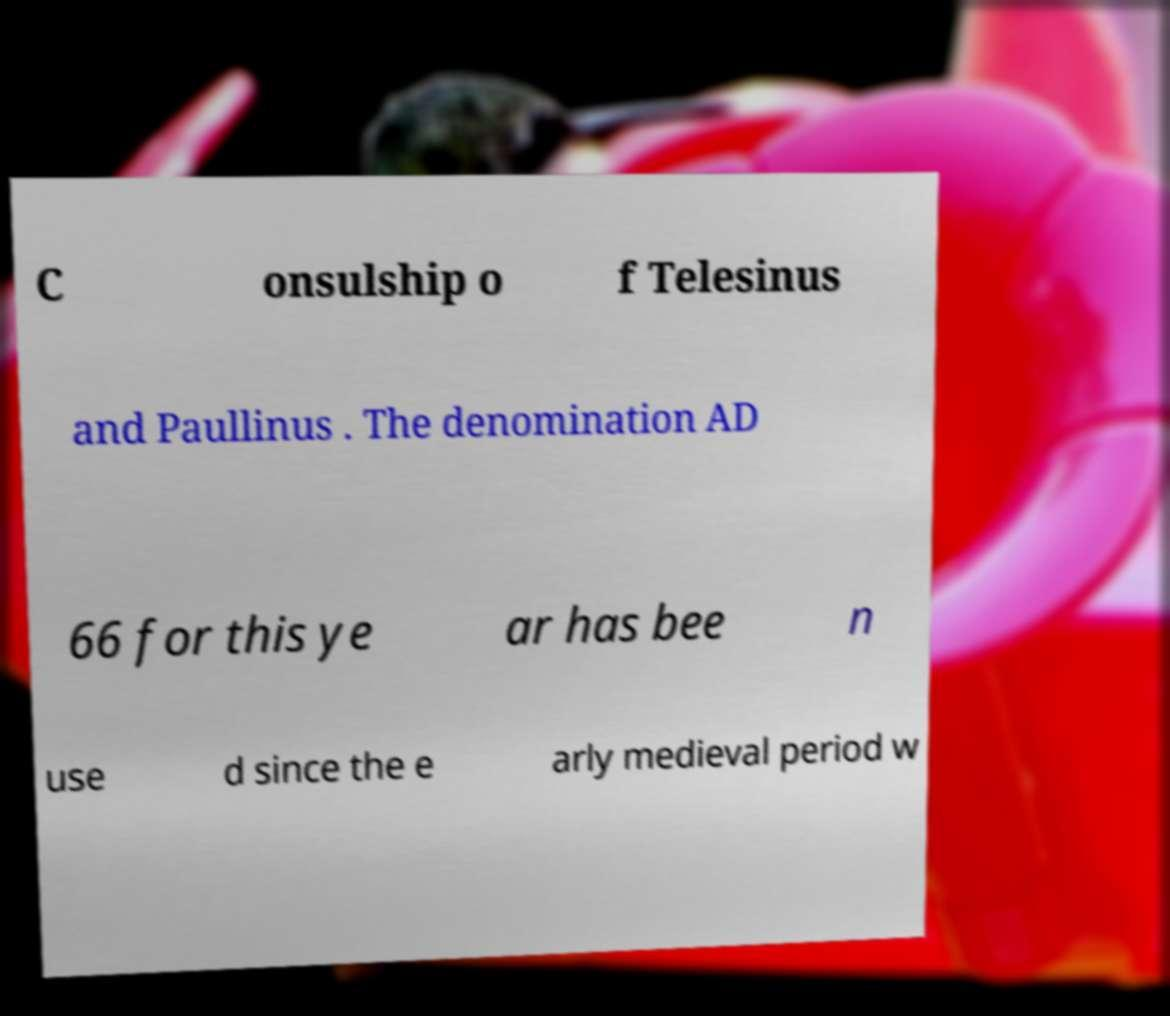Please identify and transcribe the text found in this image. C onsulship o f Telesinus and Paullinus . The denomination AD 66 for this ye ar has bee n use d since the e arly medieval period w 